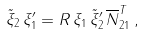Convert formula to latex. <formula><loc_0><loc_0><loc_500><loc_500>\tilde { \xi } _ { 2 } \, \xi _ { 1 } ^ { \prime } = R \, \xi _ { 1 } \, \tilde { \xi } _ { 2 } ^ { \prime } \, \overline { N } _ { 2 1 } ^ { T } \, ,</formula> 